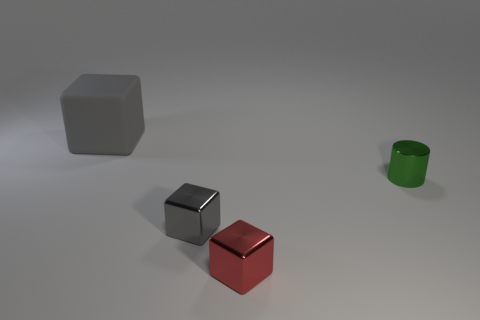Add 1 small shiny blocks. How many objects exist? 5 Subtract all cubes. How many objects are left? 1 Add 4 small green objects. How many small green objects exist? 5 Subtract 1 green cylinders. How many objects are left? 3 Subtract all green metallic objects. Subtract all big red rubber spheres. How many objects are left? 3 Add 2 cubes. How many cubes are left? 5 